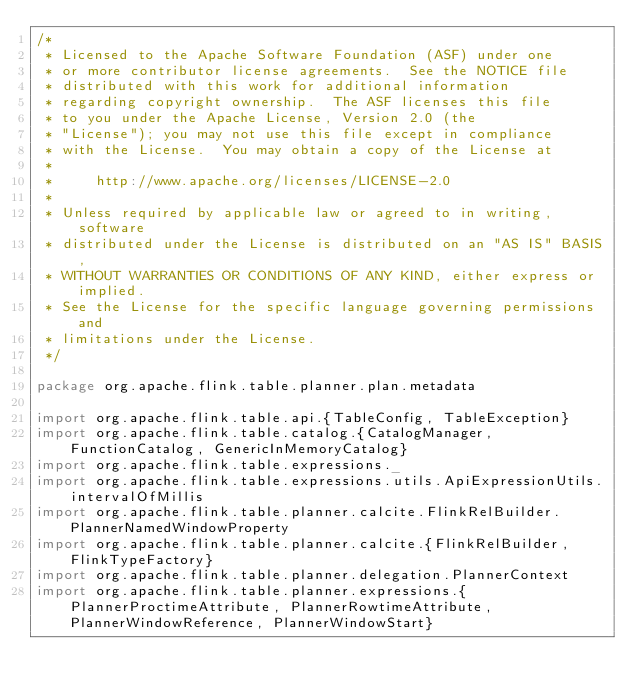Convert code to text. <code><loc_0><loc_0><loc_500><loc_500><_Scala_>/*
 * Licensed to the Apache Software Foundation (ASF) under one
 * or more contributor license agreements.  See the NOTICE file
 * distributed with this work for additional information
 * regarding copyright ownership.  The ASF licenses this file
 * to you under the Apache License, Version 2.0 (the
 * "License"); you may not use this file except in compliance
 * with the License.  You may obtain a copy of the License at
 *
 *     http://www.apache.org/licenses/LICENSE-2.0
 *
 * Unless required by applicable law or agreed to in writing, software
 * distributed under the License is distributed on an "AS IS" BASIS,
 * WITHOUT WARRANTIES OR CONDITIONS OF ANY KIND, either express or implied.
 * See the License for the specific language governing permissions and
 * limitations under the License.
 */

package org.apache.flink.table.planner.plan.metadata

import org.apache.flink.table.api.{TableConfig, TableException}
import org.apache.flink.table.catalog.{CatalogManager, FunctionCatalog, GenericInMemoryCatalog}
import org.apache.flink.table.expressions._
import org.apache.flink.table.expressions.utils.ApiExpressionUtils.intervalOfMillis
import org.apache.flink.table.planner.calcite.FlinkRelBuilder.PlannerNamedWindowProperty
import org.apache.flink.table.planner.calcite.{FlinkRelBuilder, FlinkTypeFactory}
import org.apache.flink.table.planner.delegation.PlannerContext
import org.apache.flink.table.planner.expressions.{PlannerProctimeAttribute, PlannerRowtimeAttribute, PlannerWindowReference, PlannerWindowStart}</code> 